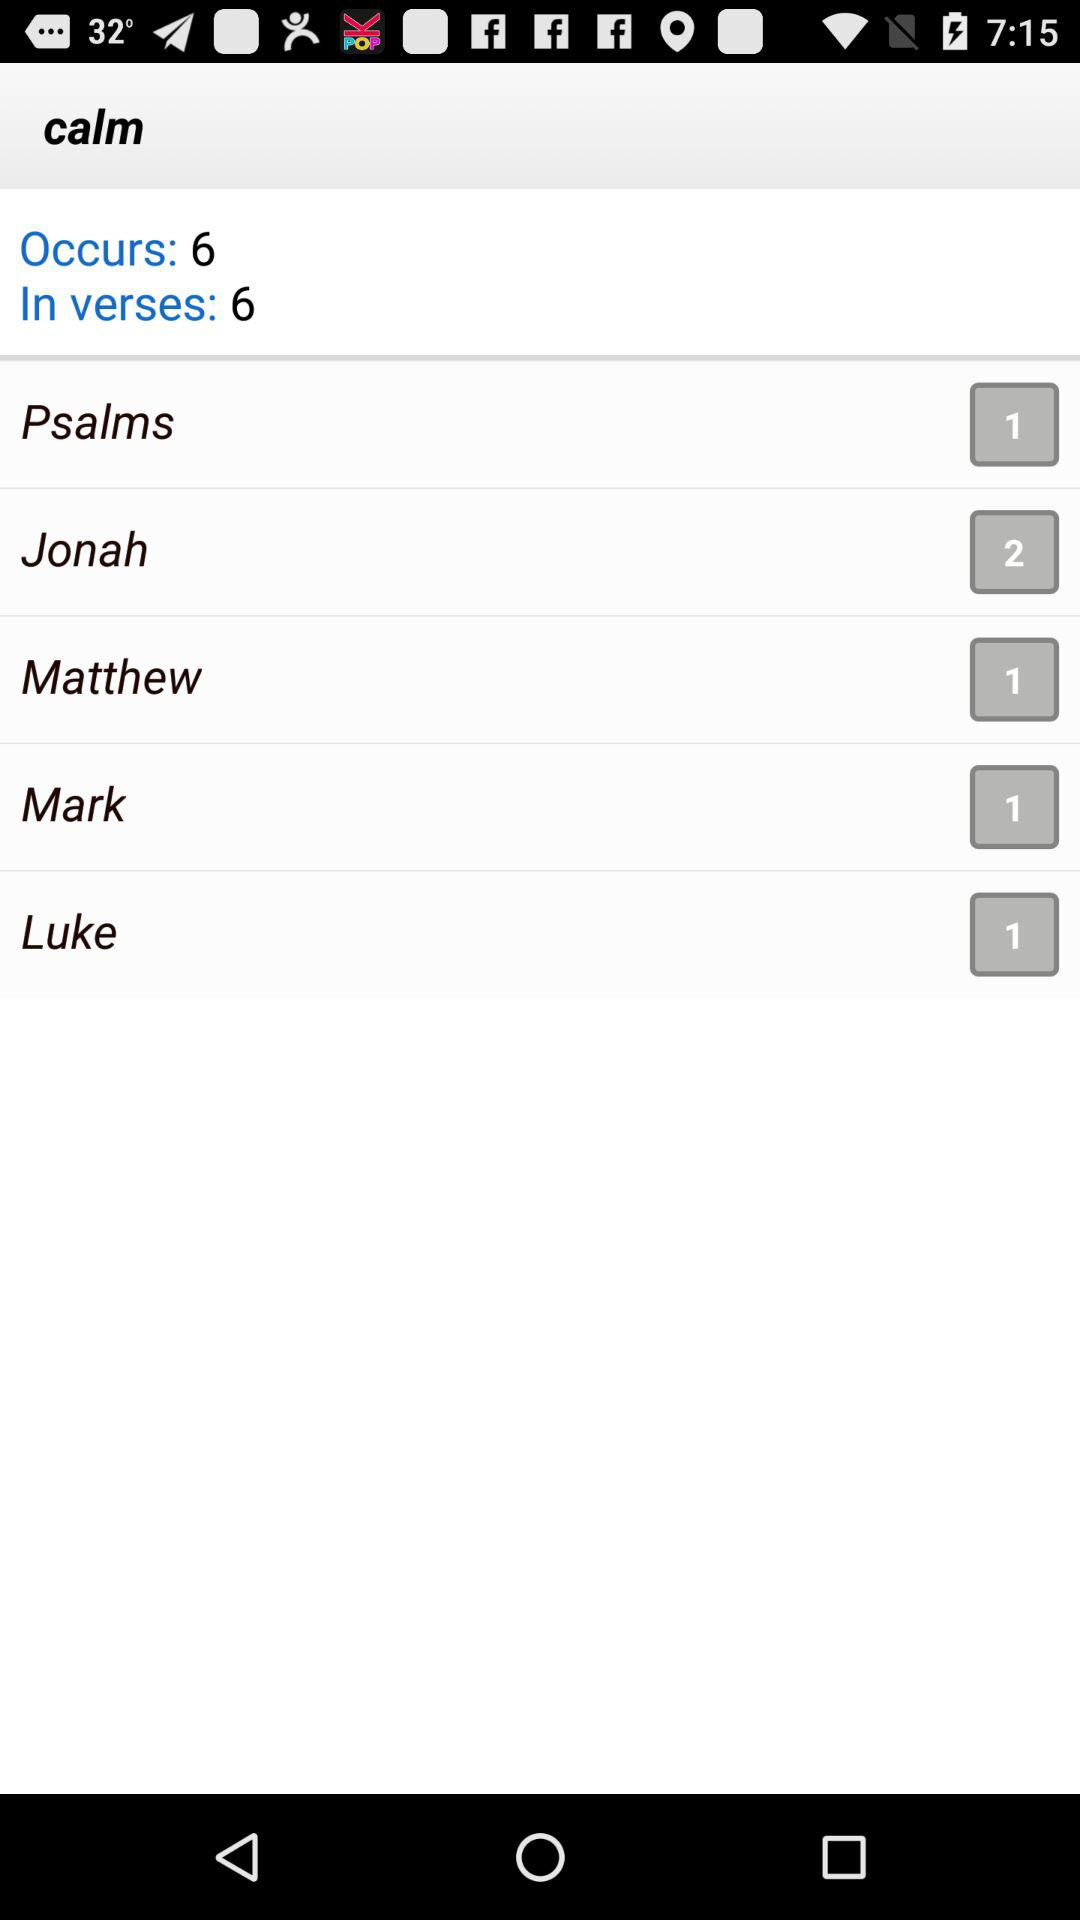What is the number of Luke? The number of Luke is 1. 